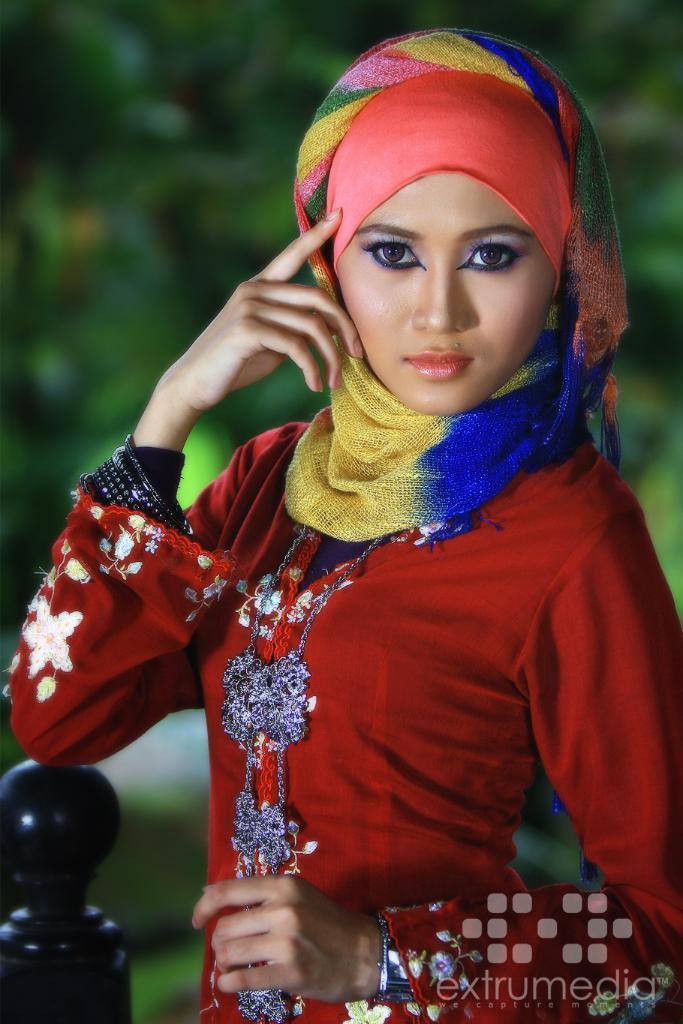In one or two sentences, can you explain what this image depicts? This woman wore a scarf and red dress. Background it is blur. Bottom of the image there is a watermark.  